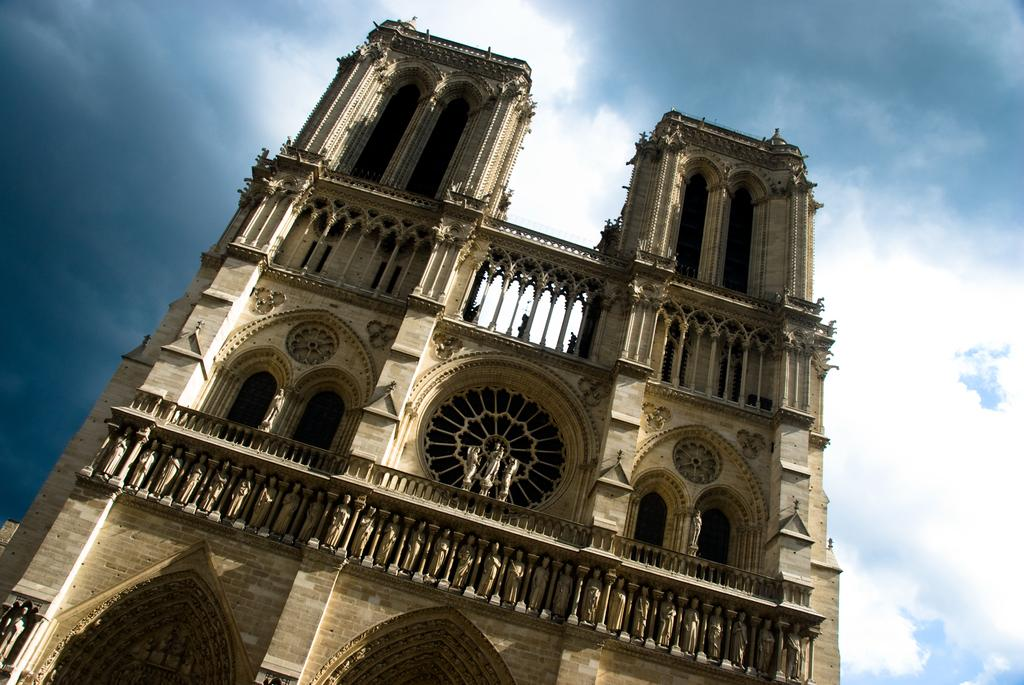What type of structure is visible in the image? There is a building in the image. What decorative elements can be seen in the image? There are statues in the image. What architectural feature is present in the building? There are windows in the image. What can be seen in the background of the image? The sky is visible in the background of the image. What is the weather like in the image? Clouds are present in the sky, indicating that it might be partly cloudy. Can you tell me how many snails are crawling on the statues in the image? There are no snails present on the statues in the image. What type of plantation can be seen in the background of the image? There is no plantation visible in the image; it features a building, statues, windows, and a sky with clouds. 